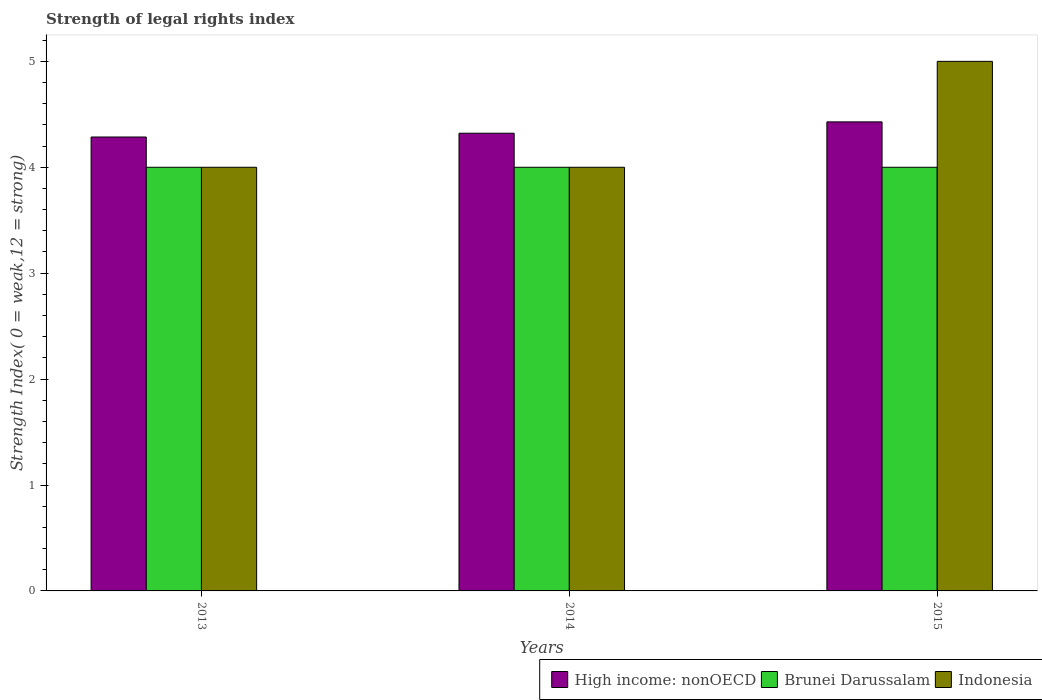Are the number of bars per tick equal to the number of legend labels?
Your response must be concise. Yes. How many bars are there on the 2nd tick from the left?
Keep it short and to the point. 3. What is the label of the 2nd group of bars from the left?
Offer a very short reply. 2014. In how many cases, is the number of bars for a given year not equal to the number of legend labels?
Your answer should be very brief. 0. What is the strength index in Indonesia in 2013?
Keep it short and to the point. 4. Across all years, what is the maximum strength index in Brunei Darussalam?
Your answer should be very brief. 4. Across all years, what is the minimum strength index in High income: nonOECD?
Your answer should be very brief. 4.29. In which year was the strength index in Indonesia minimum?
Your answer should be very brief. 2013. What is the total strength index in Brunei Darussalam in the graph?
Provide a succinct answer. 12. What is the difference between the strength index in High income: nonOECD in 2013 and that in 2015?
Offer a very short reply. -0.14. What is the difference between the strength index in High income: nonOECD in 2015 and the strength index in Brunei Darussalam in 2013?
Your answer should be very brief. 0.43. What is the average strength index in Indonesia per year?
Make the answer very short. 4.33. In the year 2015, what is the difference between the strength index in Brunei Darussalam and strength index in Indonesia?
Your answer should be compact. -1. Is the strength index in Indonesia in 2014 less than that in 2015?
Your response must be concise. Yes. Is the difference between the strength index in Brunei Darussalam in 2013 and 2014 greater than the difference between the strength index in Indonesia in 2013 and 2014?
Offer a terse response. No. What is the difference between the highest and the lowest strength index in Brunei Darussalam?
Offer a very short reply. 0. What does the 3rd bar from the left in 2013 represents?
Provide a short and direct response. Indonesia. What does the 3rd bar from the right in 2013 represents?
Provide a short and direct response. High income: nonOECD. How many bars are there?
Make the answer very short. 9. Are all the bars in the graph horizontal?
Offer a very short reply. No. How many years are there in the graph?
Your answer should be compact. 3. Are the values on the major ticks of Y-axis written in scientific E-notation?
Provide a succinct answer. No. Does the graph contain any zero values?
Provide a short and direct response. No. Does the graph contain grids?
Offer a terse response. No. How are the legend labels stacked?
Your answer should be compact. Horizontal. What is the title of the graph?
Make the answer very short. Strength of legal rights index. What is the label or title of the Y-axis?
Provide a succinct answer. Strength Index( 0 = weak,12 = strong). What is the Strength Index( 0 = weak,12 = strong) in High income: nonOECD in 2013?
Your answer should be compact. 4.29. What is the Strength Index( 0 = weak,12 = strong) of High income: nonOECD in 2014?
Your answer should be very brief. 4.32. What is the Strength Index( 0 = weak,12 = strong) in Brunei Darussalam in 2014?
Offer a very short reply. 4. What is the Strength Index( 0 = weak,12 = strong) in Indonesia in 2014?
Provide a short and direct response. 4. What is the Strength Index( 0 = weak,12 = strong) of High income: nonOECD in 2015?
Your answer should be compact. 4.43. What is the Strength Index( 0 = weak,12 = strong) of Brunei Darussalam in 2015?
Your answer should be very brief. 4. Across all years, what is the maximum Strength Index( 0 = weak,12 = strong) of High income: nonOECD?
Offer a very short reply. 4.43. Across all years, what is the maximum Strength Index( 0 = weak,12 = strong) of Brunei Darussalam?
Your answer should be compact. 4. Across all years, what is the minimum Strength Index( 0 = weak,12 = strong) in High income: nonOECD?
Provide a succinct answer. 4.29. Across all years, what is the minimum Strength Index( 0 = weak,12 = strong) in Brunei Darussalam?
Provide a succinct answer. 4. What is the total Strength Index( 0 = weak,12 = strong) of High income: nonOECD in the graph?
Give a very brief answer. 13.04. What is the total Strength Index( 0 = weak,12 = strong) of Indonesia in the graph?
Provide a short and direct response. 13. What is the difference between the Strength Index( 0 = weak,12 = strong) of High income: nonOECD in 2013 and that in 2014?
Your answer should be compact. -0.04. What is the difference between the Strength Index( 0 = weak,12 = strong) of Brunei Darussalam in 2013 and that in 2014?
Give a very brief answer. 0. What is the difference between the Strength Index( 0 = weak,12 = strong) in High income: nonOECD in 2013 and that in 2015?
Provide a succinct answer. -0.14. What is the difference between the Strength Index( 0 = weak,12 = strong) in High income: nonOECD in 2014 and that in 2015?
Give a very brief answer. -0.11. What is the difference between the Strength Index( 0 = weak,12 = strong) of Brunei Darussalam in 2014 and that in 2015?
Your response must be concise. 0. What is the difference between the Strength Index( 0 = weak,12 = strong) of Indonesia in 2014 and that in 2015?
Make the answer very short. -1. What is the difference between the Strength Index( 0 = weak,12 = strong) in High income: nonOECD in 2013 and the Strength Index( 0 = weak,12 = strong) in Brunei Darussalam in 2014?
Your answer should be compact. 0.29. What is the difference between the Strength Index( 0 = weak,12 = strong) of High income: nonOECD in 2013 and the Strength Index( 0 = weak,12 = strong) of Indonesia in 2014?
Ensure brevity in your answer.  0.29. What is the difference between the Strength Index( 0 = weak,12 = strong) of High income: nonOECD in 2013 and the Strength Index( 0 = weak,12 = strong) of Brunei Darussalam in 2015?
Make the answer very short. 0.29. What is the difference between the Strength Index( 0 = weak,12 = strong) in High income: nonOECD in 2013 and the Strength Index( 0 = weak,12 = strong) in Indonesia in 2015?
Your answer should be very brief. -0.71. What is the difference between the Strength Index( 0 = weak,12 = strong) of High income: nonOECD in 2014 and the Strength Index( 0 = weak,12 = strong) of Brunei Darussalam in 2015?
Your answer should be compact. 0.32. What is the difference between the Strength Index( 0 = weak,12 = strong) of High income: nonOECD in 2014 and the Strength Index( 0 = weak,12 = strong) of Indonesia in 2015?
Keep it short and to the point. -0.68. What is the difference between the Strength Index( 0 = weak,12 = strong) in Brunei Darussalam in 2014 and the Strength Index( 0 = weak,12 = strong) in Indonesia in 2015?
Ensure brevity in your answer.  -1. What is the average Strength Index( 0 = weak,12 = strong) of High income: nonOECD per year?
Your response must be concise. 4.35. What is the average Strength Index( 0 = weak,12 = strong) in Brunei Darussalam per year?
Your response must be concise. 4. What is the average Strength Index( 0 = weak,12 = strong) of Indonesia per year?
Make the answer very short. 4.33. In the year 2013, what is the difference between the Strength Index( 0 = weak,12 = strong) in High income: nonOECD and Strength Index( 0 = weak,12 = strong) in Brunei Darussalam?
Provide a short and direct response. 0.29. In the year 2013, what is the difference between the Strength Index( 0 = weak,12 = strong) of High income: nonOECD and Strength Index( 0 = weak,12 = strong) of Indonesia?
Provide a succinct answer. 0.29. In the year 2013, what is the difference between the Strength Index( 0 = weak,12 = strong) in Brunei Darussalam and Strength Index( 0 = weak,12 = strong) in Indonesia?
Offer a terse response. 0. In the year 2014, what is the difference between the Strength Index( 0 = weak,12 = strong) in High income: nonOECD and Strength Index( 0 = weak,12 = strong) in Brunei Darussalam?
Your answer should be very brief. 0.32. In the year 2014, what is the difference between the Strength Index( 0 = weak,12 = strong) of High income: nonOECD and Strength Index( 0 = weak,12 = strong) of Indonesia?
Your answer should be compact. 0.32. In the year 2015, what is the difference between the Strength Index( 0 = weak,12 = strong) of High income: nonOECD and Strength Index( 0 = weak,12 = strong) of Brunei Darussalam?
Give a very brief answer. 0.43. In the year 2015, what is the difference between the Strength Index( 0 = weak,12 = strong) in High income: nonOECD and Strength Index( 0 = weak,12 = strong) in Indonesia?
Your response must be concise. -0.57. In the year 2015, what is the difference between the Strength Index( 0 = weak,12 = strong) in Brunei Darussalam and Strength Index( 0 = weak,12 = strong) in Indonesia?
Offer a terse response. -1. What is the ratio of the Strength Index( 0 = weak,12 = strong) in High income: nonOECD in 2013 to that in 2014?
Offer a very short reply. 0.99. What is the ratio of the Strength Index( 0 = weak,12 = strong) of Brunei Darussalam in 2013 to that in 2014?
Your answer should be compact. 1. What is the ratio of the Strength Index( 0 = weak,12 = strong) in Indonesia in 2013 to that in 2014?
Provide a succinct answer. 1. What is the ratio of the Strength Index( 0 = weak,12 = strong) in High income: nonOECD in 2013 to that in 2015?
Make the answer very short. 0.97. What is the ratio of the Strength Index( 0 = weak,12 = strong) in Brunei Darussalam in 2013 to that in 2015?
Your answer should be compact. 1. What is the ratio of the Strength Index( 0 = weak,12 = strong) in High income: nonOECD in 2014 to that in 2015?
Provide a short and direct response. 0.98. What is the ratio of the Strength Index( 0 = weak,12 = strong) of Brunei Darussalam in 2014 to that in 2015?
Make the answer very short. 1. What is the ratio of the Strength Index( 0 = weak,12 = strong) of Indonesia in 2014 to that in 2015?
Provide a short and direct response. 0.8. What is the difference between the highest and the second highest Strength Index( 0 = weak,12 = strong) in High income: nonOECD?
Offer a terse response. 0.11. What is the difference between the highest and the second highest Strength Index( 0 = weak,12 = strong) in Indonesia?
Offer a terse response. 1. What is the difference between the highest and the lowest Strength Index( 0 = weak,12 = strong) of High income: nonOECD?
Provide a succinct answer. 0.14. What is the difference between the highest and the lowest Strength Index( 0 = weak,12 = strong) of Brunei Darussalam?
Keep it short and to the point. 0. 